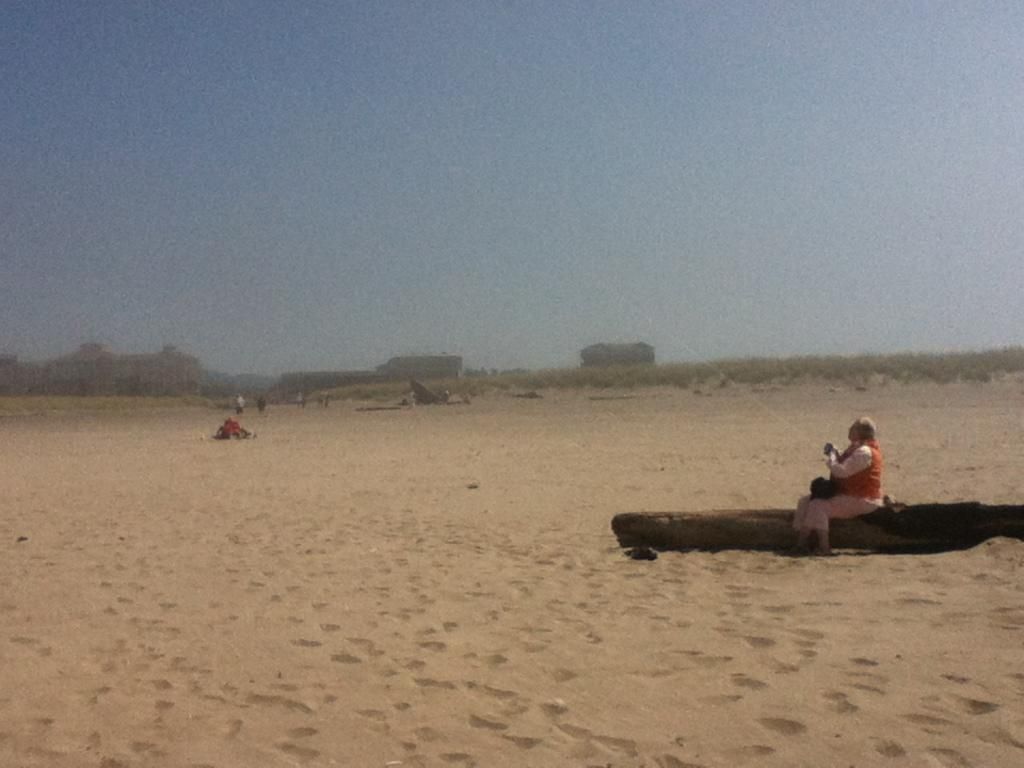What is the person in the image sitting on? The person is sitting on a wooden platform. What is the surface beneath the wooden platform? The wooden platform is on sand. What can be seen in the background of the image? The sky is visible in the background of the image. How many ducks are swimming in the water near the person in the image? There are no ducks or water present in the image; it features a person sitting on a wooden platform on sand with the sky visible in the background. 